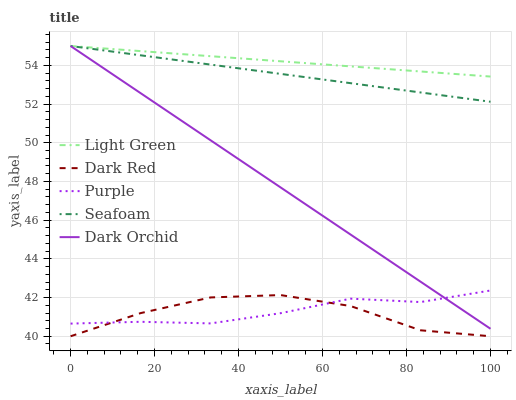Does Dark Red have the minimum area under the curve?
Answer yes or no. Yes. Does Light Green have the maximum area under the curve?
Answer yes or no. Yes. Does Dark Orchid have the minimum area under the curve?
Answer yes or no. No. Does Dark Orchid have the maximum area under the curve?
Answer yes or no. No. Is Seafoam the smoothest?
Answer yes or no. Yes. Is Dark Red the roughest?
Answer yes or no. Yes. Is Dark Orchid the smoothest?
Answer yes or no. No. Is Dark Orchid the roughest?
Answer yes or no. No. Does Dark Red have the lowest value?
Answer yes or no. Yes. Does Dark Orchid have the lowest value?
Answer yes or no. No. Does Light Green have the highest value?
Answer yes or no. Yes. Does Dark Red have the highest value?
Answer yes or no. No. Is Purple less than Seafoam?
Answer yes or no. Yes. Is Seafoam greater than Purple?
Answer yes or no. Yes. Does Dark Orchid intersect Light Green?
Answer yes or no. Yes. Is Dark Orchid less than Light Green?
Answer yes or no. No. Is Dark Orchid greater than Light Green?
Answer yes or no. No. Does Purple intersect Seafoam?
Answer yes or no. No. 